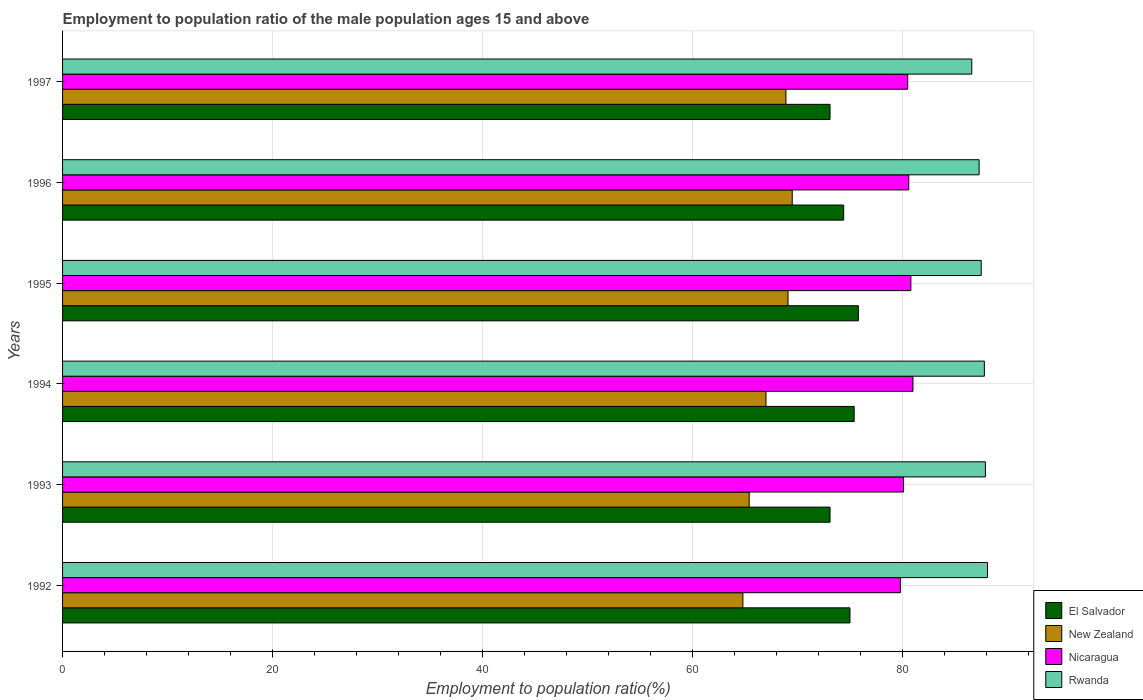How many groups of bars are there?
Keep it short and to the point. 6. Are the number of bars per tick equal to the number of legend labels?
Your response must be concise. Yes. How many bars are there on the 6th tick from the top?
Provide a short and direct response. 4. What is the label of the 5th group of bars from the top?
Give a very brief answer. 1993. What is the employment to population ratio in New Zealand in 1995?
Your response must be concise. 69.1. Across all years, what is the maximum employment to population ratio in El Salvador?
Provide a short and direct response. 75.8. Across all years, what is the minimum employment to population ratio in Nicaragua?
Provide a short and direct response. 79.8. In which year was the employment to population ratio in New Zealand maximum?
Ensure brevity in your answer.  1996. What is the total employment to population ratio in Nicaragua in the graph?
Offer a very short reply. 482.8. What is the difference between the employment to population ratio in Nicaragua in 1993 and that in 1997?
Keep it short and to the point. -0.4. What is the difference between the employment to population ratio in Nicaragua in 1992 and the employment to population ratio in El Salvador in 1994?
Your answer should be compact. 4.4. What is the average employment to population ratio in El Salvador per year?
Your response must be concise. 74.47. In the year 1993, what is the difference between the employment to population ratio in Rwanda and employment to population ratio in Nicaragua?
Offer a very short reply. 7.8. In how many years, is the employment to population ratio in Nicaragua greater than 76 %?
Ensure brevity in your answer.  6. What is the ratio of the employment to population ratio in New Zealand in 1992 to that in 1993?
Provide a succinct answer. 0.99. What is the difference between the highest and the second highest employment to population ratio in Nicaragua?
Provide a short and direct response. 0.2. What is the difference between the highest and the lowest employment to population ratio in Rwanda?
Your answer should be very brief. 1.5. Is the sum of the employment to population ratio in Rwanda in 1994 and 1996 greater than the maximum employment to population ratio in New Zealand across all years?
Ensure brevity in your answer.  Yes. Is it the case that in every year, the sum of the employment to population ratio in Nicaragua and employment to population ratio in Rwanda is greater than the sum of employment to population ratio in New Zealand and employment to population ratio in El Salvador?
Make the answer very short. Yes. What does the 1st bar from the top in 1997 represents?
Give a very brief answer. Rwanda. What does the 3rd bar from the bottom in 1993 represents?
Provide a short and direct response. Nicaragua. Is it the case that in every year, the sum of the employment to population ratio in Nicaragua and employment to population ratio in El Salvador is greater than the employment to population ratio in New Zealand?
Your answer should be compact. Yes. Are all the bars in the graph horizontal?
Your answer should be compact. Yes. How many years are there in the graph?
Your answer should be compact. 6. What is the difference between two consecutive major ticks on the X-axis?
Offer a terse response. 20. Are the values on the major ticks of X-axis written in scientific E-notation?
Your answer should be compact. No. Does the graph contain any zero values?
Your answer should be compact. No. How many legend labels are there?
Ensure brevity in your answer.  4. What is the title of the graph?
Offer a terse response. Employment to population ratio of the male population ages 15 and above. What is the label or title of the X-axis?
Keep it short and to the point. Employment to population ratio(%). What is the label or title of the Y-axis?
Your answer should be compact. Years. What is the Employment to population ratio(%) of El Salvador in 1992?
Your answer should be very brief. 75. What is the Employment to population ratio(%) of New Zealand in 1992?
Ensure brevity in your answer.  64.8. What is the Employment to population ratio(%) of Nicaragua in 1992?
Your answer should be compact. 79.8. What is the Employment to population ratio(%) of Rwanda in 1992?
Offer a very short reply. 88.1. What is the Employment to population ratio(%) in El Salvador in 1993?
Your answer should be very brief. 73.1. What is the Employment to population ratio(%) of New Zealand in 1993?
Provide a succinct answer. 65.4. What is the Employment to population ratio(%) in Nicaragua in 1993?
Provide a short and direct response. 80.1. What is the Employment to population ratio(%) of Rwanda in 1993?
Offer a terse response. 87.9. What is the Employment to population ratio(%) in El Salvador in 1994?
Your answer should be compact. 75.4. What is the Employment to population ratio(%) in New Zealand in 1994?
Provide a short and direct response. 67. What is the Employment to population ratio(%) of Nicaragua in 1994?
Keep it short and to the point. 81. What is the Employment to population ratio(%) of Rwanda in 1994?
Provide a succinct answer. 87.8. What is the Employment to population ratio(%) of El Salvador in 1995?
Your answer should be compact. 75.8. What is the Employment to population ratio(%) of New Zealand in 1995?
Offer a terse response. 69.1. What is the Employment to population ratio(%) of Nicaragua in 1995?
Offer a terse response. 80.8. What is the Employment to population ratio(%) in Rwanda in 1995?
Provide a short and direct response. 87.5. What is the Employment to population ratio(%) in El Salvador in 1996?
Your answer should be compact. 74.4. What is the Employment to population ratio(%) in New Zealand in 1996?
Ensure brevity in your answer.  69.5. What is the Employment to population ratio(%) of Nicaragua in 1996?
Keep it short and to the point. 80.6. What is the Employment to population ratio(%) in Rwanda in 1996?
Offer a terse response. 87.3. What is the Employment to population ratio(%) in El Salvador in 1997?
Your answer should be compact. 73.1. What is the Employment to population ratio(%) in New Zealand in 1997?
Your response must be concise. 68.9. What is the Employment to population ratio(%) of Nicaragua in 1997?
Provide a short and direct response. 80.5. What is the Employment to population ratio(%) of Rwanda in 1997?
Provide a short and direct response. 86.6. Across all years, what is the maximum Employment to population ratio(%) of El Salvador?
Provide a short and direct response. 75.8. Across all years, what is the maximum Employment to population ratio(%) in New Zealand?
Your response must be concise. 69.5. Across all years, what is the maximum Employment to population ratio(%) of Rwanda?
Offer a very short reply. 88.1. Across all years, what is the minimum Employment to population ratio(%) of El Salvador?
Your response must be concise. 73.1. Across all years, what is the minimum Employment to population ratio(%) of New Zealand?
Give a very brief answer. 64.8. Across all years, what is the minimum Employment to population ratio(%) of Nicaragua?
Provide a succinct answer. 79.8. Across all years, what is the minimum Employment to population ratio(%) in Rwanda?
Make the answer very short. 86.6. What is the total Employment to population ratio(%) in El Salvador in the graph?
Offer a very short reply. 446.8. What is the total Employment to population ratio(%) of New Zealand in the graph?
Offer a terse response. 404.7. What is the total Employment to population ratio(%) in Nicaragua in the graph?
Give a very brief answer. 482.8. What is the total Employment to population ratio(%) in Rwanda in the graph?
Provide a short and direct response. 525.2. What is the difference between the Employment to population ratio(%) in El Salvador in 1992 and that in 1993?
Provide a short and direct response. 1.9. What is the difference between the Employment to population ratio(%) of Nicaragua in 1992 and that in 1993?
Offer a terse response. -0.3. What is the difference between the Employment to population ratio(%) in El Salvador in 1992 and that in 1994?
Make the answer very short. -0.4. What is the difference between the Employment to population ratio(%) of New Zealand in 1992 and that in 1994?
Keep it short and to the point. -2.2. What is the difference between the Employment to population ratio(%) of El Salvador in 1992 and that in 1995?
Keep it short and to the point. -0.8. What is the difference between the Employment to population ratio(%) in Rwanda in 1992 and that in 1995?
Keep it short and to the point. 0.6. What is the difference between the Employment to population ratio(%) in El Salvador in 1992 and that in 1996?
Make the answer very short. 0.6. What is the difference between the Employment to population ratio(%) in New Zealand in 1992 and that in 1996?
Offer a very short reply. -4.7. What is the difference between the Employment to population ratio(%) of Nicaragua in 1992 and that in 1996?
Give a very brief answer. -0.8. What is the difference between the Employment to population ratio(%) in Rwanda in 1992 and that in 1996?
Ensure brevity in your answer.  0.8. What is the difference between the Employment to population ratio(%) of New Zealand in 1992 and that in 1997?
Provide a succinct answer. -4.1. What is the difference between the Employment to population ratio(%) in Nicaragua in 1992 and that in 1997?
Keep it short and to the point. -0.7. What is the difference between the Employment to population ratio(%) in El Salvador in 1993 and that in 1994?
Provide a succinct answer. -2.3. What is the difference between the Employment to population ratio(%) of Nicaragua in 1993 and that in 1994?
Offer a terse response. -0.9. What is the difference between the Employment to population ratio(%) in El Salvador in 1993 and that in 1995?
Provide a succinct answer. -2.7. What is the difference between the Employment to population ratio(%) in Rwanda in 1993 and that in 1995?
Ensure brevity in your answer.  0.4. What is the difference between the Employment to population ratio(%) of El Salvador in 1993 and that in 1996?
Offer a terse response. -1.3. What is the difference between the Employment to population ratio(%) of New Zealand in 1993 and that in 1996?
Offer a terse response. -4.1. What is the difference between the Employment to population ratio(%) of El Salvador in 1993 and that in 1997?
Your response must be concise. 0. What is the difference between the Employment to population ratio(%) in New Zealand in 1993 and that in 1997?
Ensure brevity in your answer.  -3.5. What is the difference between the Employment to population ratio(%) in Rwanda in 1993 and that in 1997?
Your response must be concise. 1.3. What is the difference between the Employment to population ratio(%) of El Salvador in 1994 and that in 1995?
Provide a succinct answer. -0.4. What is the difference between the Employment to population ratio(%) of New Zealand in 1994 and that in 1995?
Your answer should be very brief. -2.1. What is the difference between the Employment to population ratio(%) in El Salvador in 1994 and that in 1996?
Make the answer very short. 1. What is the difference between the Employment to population ratio(%) of New Zealand in 1994 and that in 1996?
Your answer should be very brief. -2.5. What is the difference between the Employment to population ratio(%) in Rwanda in 1994 and that in 1996?
Give a very brief answer. 0.5. What is the difference between the Employment to population ratio(%) in New Zealand in 1994 and that in 1997?
Make the answer very short. -1.9. What is the difference between the Employment to population ratio(%) in Rwanda in 1994 and that in 1997?
Make the answer very short. 1.2. What is the difference between the Employment to population ratio(%) of New Zealand in 1995 and that in 1996?
Offer a terse response. -0.4. What is the difference between the Employment to population ratio(%) of Rwanda in 1995 and that in 1996?
Ensure brevity in your answer.  0.2. What is the difference between the Employment to population ratio(%) in El Salvador in 1995 and that in 1997?
Your answer should be very brief. 2.7. What is the difference between the Employment to population ratio(%) in New Zealand in 1995 and that in 1997?
Your answer should be very brief. 0.2. What is the difference between the Employment to population ratio(%) in Nicaragua in 1995 and that in 1997?
Offer a terse response. 0.3. What is the difference between the Employment to population ratio(%) in Rwanda in 1995 and that in 1997?
Ensure brevity in your answer.  0.9. What is the difference between the Employment to population ratio(%) in New Zealand in 1996 and that in 1997?
Offer a very short reply. 0.6. What is the difference between the Employment to population ratio(%) in Nicaragua in 1996 and that in 1997?
Offer a very short reply. 0.1. What is the difference between the Employment to population ratio(%) in El Salvador in 1992 and the Employment to population ratio(%) in New Zealand in 1993?
Your answer should be very brief. 9.6. What is the difference between the Employment to population ratio(%) of El Salvador in 1992 and the Employment to population ratio(%) of Nicaragua in 1993?
Keep it short and to the point. -5.1. What is the difference between the Employment to population ratio(%) in New Zealand in 1992 and the Employment to population ratio(%) in Nicaragua in 1993?
Offer a very short reply. -15.3. What is the difference between the Employment to population ratio(%) in New Zealand in 1992 and the Employment to population ratio(%) in Rwanda in 1993?
Give a very brief answer. -23.1. What is the difference between the Employment to population ratio(%) of Nicaragua in 1992 and the Employment to population ratio(%) of Rwanda in 1993?
Give a very brief answer. -8.1. What is the difference between the Employment to population ratio(%) of El Salvador in 1992 and the Employment to population ratio(%) of New Zealand in 1994?
Give a very brief answer. 8. What is the difference between the Employment to population ratio(%) of El Salvador in 1992 and the Employment to population ratio(%) of Rwanda in 1994?
Give a very brief answer. -12.8. What is the difference between the Employment to population ratio(%) of New Zealand in 1992 and the Employment to population ratio(%) of Nicaragua in 1994?
Give a very brief answer. -16.2. What is the difference between the Employment to population ratio(%) in Nicaragua in 1992 and the Employment to population ratio(%) in Rwanda in 1994?
Your answer should be compact. -8. What is the difference between the Employment to population ratio(%) of El Salvador in 1992 and the Employment to population ratio(%) of Nicaragua in 1995?
Your answer should be very brief. -5.8. What is the difference between the Employment to population ratio(%) in El Salvador in 1992 and the Employment to population ratio(%) in Rwanda in 1995?
Ensure brevity in your answer.  -12.5. What is the difference between the Employment to population ratio(%) of New Zealand in 1992 and the Employment to population ratio(%) of Nicaragua in 1995?
Ensure brevity in your answer.  -16. What is the difference between the Employment to population ratio(%) of New Zealand in 1992 and the Employment to population ratio(%) of Rwanda in 1995?
Make the answer very short. -22.7. What is the difference between the Employment to population ratio(%) of Nicaragua in 1992 and the Employment to population ratio(%) of Rwanda in 1995?
Your response must be concise. -7.7. What is the difference between the Employment to population ratio(%) in El Salvador in 1992 and the Employment to population ratio(%) in New Zealand in 1996?
Offer a terse response. 5.5. What is the difference between the Employment to population ratio(%) in El Salvador in 1992 and the Employment to population ratio(%) in Nicaragua in 1996?
Your answer should be compact. -5.6. What is the difference between the Employment to population ratio(%) of El Salvador in 1992 and the Employment to population ratio(%) of Rwanda in 1996?
Provide a succinct answer. -12.3. What is the difference between the Employment to population ratio(%) of New Zealand in 1992 and the Employment to population ratio(%) of Nicaragua in 1996?
Provide a short and direct response. -15.8. What is the difference between the Employment to population ratio(%) of New Zealand in 1992 and the Employment to population ratio(%) of Rwanda in 1996?
Keep it short and to the point. -22.5. What is the difference between the Employment to population ratio(%) in Nicaragua in 1992 and the Employment to population ratio(%) in Rwanda in 1996?
Offer a terse response. -7.5. What is the difference between the Employment to population ratio(%) in El Salvador in 1992 and the Employment to population ratio(%) in New Zealand in 1997?
Provide a short and direct response. 6.1. What is the difference between the Employment to population ratio(%) in New Zealand in 1992 and the Employment to population ratio(%) in Nicaragua in 1997?
Offer a terse response. -15.7. What is the difference between the Employment to population ratio(%) in New Zealand in 1992 and the Employment to population ratio(%) in Rwanda in 1997?
Give a very brief answer. -21.8. What is the difference between the Employment to population ratio(%) of Nicaragua in 1992 and the Employment to population ratio(%) of Rwanda in 1997?
Your answer should be very brief. -6.8. What is the difference between the Employment to population ratio(%) of El Salvador in 1993 and the Employment to population ratio(%) of New Zealand in 1994?
Provide a short and direct response. 6.1. What is the difference between the Employment to population ratio(%) in El Salvador in 1993 and the Employment to population ratio(%) in Nicaragua in 1994?
Keep it short and to the point. -7.9. What is the difference between the Employment to population ratio(%) of El Salvador in 1993 and the Employment to population ratio(%) of Rwanda in 1994?
Keep it short and to the point. -14.7. What is the difference between the Employment to population ratio(%) in New Zealand in 1993 and the Employment to population ratio(%) in Nicaragua in 1994?
Make the answer very short. -15.6. What is the difference between the Employment to population ratio(%) of New Zealand in 1993 and the Employment to population ratio(%) of Rwanda in 1994?
Your answer should be very brief. -22.4. What is the difference between the Employment to population ratio(%) of El Salvador in 1993 and the Employment to population ratio(%) of Rwanda in 1995?
Your answer should be very brief. -14.4. What is the difference between the Employment to population ratio(%) in New Zealand in 1993 and the Employment to population ratio(%) in Nicaragua in 1995?
Provide a short and direct response. -15.4. What is the difference between the Employment to population ratio(%) in New Zealand in 1993 and the Employment to population ratio(%) in Rwanda in 1995?
Provide a succinct answer. -22.1. What is the difference between the Employment to population ratio(%) in El Salvador in 1993 and the Employment to population ratio(%) in New Zealand in 1996?
Give a very brief answer. 3.6. What is the difference between the Employment to population ratio(%) in New Zealand in 1993 and the Employment to population ratio(%) in Nicaragua in 1996?
Make the answer very short. -15.2. What is the difference between the Employment to population ratio(%) in New Zealand in 1993 and the Employment to population ratio(%) in Rwanda in 1996?
Provide a succinct answer. -21.9. What is the difference between the Employment to population ratio(%) of El Salvador in 1993 and the Employment to population ratio(%) of New Zealand in 1997?
Ensure brevity in your answer.  4.2. What is the difference between the Employment to population ratio(%) in El Salvador in 1993 and the Employment to population ratio(%) in Nicaragua in 1997?
Your answer should be very brief. -7.4. What is the difference between the Employment to population ratio(%) in El Salvador in 1993 and the Employment to population ratio(%) in Rwanda in 1997?
Your answer should be compact. -13.5. What is the difference between the Employment to population ratio(%) of New Zealand in 1993 and the Employment to population ratio(%) of Nicaragua in 1997?
Keep it short and to the point. -15.1. What is the difference between the Employment to population ratio(%) in New Zealand in 1993 and the Employment to population ratio(%) in Rwanda in 1997?
Provide a short and direct response. -21.2. What is the difference between the Employment to population ratio(%) of Nicaragua in 1993 and the Employment to population ratio(%) of Rwanda in 1997?
Your answer should be compact. -6.5. What is the difference between the Employment to population ratio(%) of El Salvador in 1994 and the Employment to population ratio(%) of New Zealand in 1995?
Make the answer very short. 6.3. What is the difference between the Employment to population ratio(%) in El Salvador in 1994 and the Employment to population ratio(%) in Nicaragua in 1995?
Keep it short and to the point. -5.4. What is the difference between the Employment to population ratio(%) of New Zealand in 1994 and the Employment to population ratio(%) of Nicaragua in 1995?
Provide a succinct answer. -13.8. What is the difference between the Employment to population ratio(%) of New Zealand in 1994 and the Employment to population ratio(%) of Rwanda in 1995?
Provide a succinct answer. -20.5. What is the difference between the Employment to population ratio(%) in Nicaragua in 1994 and the Employment to population ratio(%) in Rwanda in 1995?
Keep it short and to the point. -6.5. What is the difference between the Employment to population ratio(%) in El Salvador in 1994 and the Employment to population ratio(%) in New Zealand in 1996?
Make the answer very short. 5.9. What is the difference between the Employment to population ratio(%) in El Salvador in 1994 and the Employment to population ratio(%) in Rwanda in 1996?
Offer a very short reply. -11.9. What is the difference between the Employment to population ratio(%) in New Zealand in 1994 and the Employment to population ratio(%) in Rwanda in 1996?
Your answer should be very brief. -20.3. What is the difference between the Employment to population ratio(%) in Nicaragua in 1994 and the Employment to population ratio(%) in Rwanda in 1996?
Make the answer very short. -6.3. What is the difference between the Employment to population ratio(%) in El Salvador in 1994 and the Employment to population ratio(%) in Nicaragua in 1997?
Offer a very short reply. -5.1. What is the difference between the Employment to population ratio(%) in El Salvador in 1994 and the Employment to population ratio(%) in Rwanda in 1997?
Provide a short and direct response. -11.2. What is the difference between the Employment to population ratio(%) in New Zealand in 1994 and the Employment to population ratio(%) in Rwanda in 1997?
Offer a very short reply. -19.6. What is the difference between the Employment to population ratio(%) of Nicaragua in 1994 and the Employment to population ratio(%) of Rwanda in 1997?
Make the answer very short. -5.6. What is the difference between the Employment to population ratio(%) in El Salvador in 1995 and the Employment to population ratio(%) in Nicaragua in 1996?
Provide a short and direct response. -4.8. What is the difference between the Employment to population ratio(%) in New Zealand in 1995 and the Employment to population ratio(%) in Nicaragua in 1996?
Ensure brevity in your answer.  -11.5. What is the difference between the Employment to population ratio(%) in New Zealand in 1995 and the Employment to population ratio(%) in Rwanda in 1996?
Your response must be concise. -18.2. What is the difference between the Employment to population ratio(%) of New Zealand in 1995 and the Employment to population ratio(%) of Rwanda in 1997?
Give a very brief answer. -17.5. What is the difference between the Employment to population ratio(%) of Nicaragua in 1995 and the Employment to population ratio(%) of Rwanda in 1997?
Offer a terse response. -5.8. What is the difference between the Employment to population ratio(%) of El Salvador in 1996 and the Employment to population ratio(%) of Nicaragua in 1997?
Your response must be concise. -6.1. What is the difference between the Employment to population ratio(%) of New Zealand in 1996 and the Employment to population ratio(%) of Nicaragua in 1997?
Offer a terse response. -11. What is the difference between the Employment to population ratio(%) of New Zealand in 1996 and the Employment to population ratio(%) of Rwanda in 1997?
Provide a short and direct response. -17.1. What is the average Employment to population ratio(%) of El Salvador per year?
Provide a short and direct response. 74.47. What is the average Employment to population ratio(%) in New Zealand per year?
Offer a terse response. 67.45. What is the average Employment to population ratio(%) in Nicaragua per year?
Your answer should be very brief. 80.47. What is the average Employment to population ratio(%) of Rwanda per year?
Make the answer very short. 87.53. In the year 1992, what is the difference between the Employment to population ratio(%) of New Zealand and Employment to population ratio(%) of Nicaragua?
Give a very brief answer. -15. In the year 1992, what is the difference between the Employment to population ratio(%) in New Zealand and Employment to population ratio(%) in Rwanda?
Your response must be concise. -23.3. In the year 1993, what is the difference between the Employment to population ratio(%) in El Salvador and Employment to population ratio(%) in New Zealand?
Keep it short and to the point. 7.7. In the year 1993, what is the difference between the Employment to population ratio(%) in El Salvador and Employment to population ratio(%) in Rwanda?
Your answer should be compact. -14.8. In the year 1993, what is the difference between the Employment to population ratio(%) in New Zealand and Employment to population ratio(%) in Nicaragua?
Ensure brevity in your answer.  -14.7. In the year 1993, what is the difference between the Employment to population ratio(%) in New Zealand and Employment to population ratio(%) in Rwanda?
Your response must be concise. -22.5. In the year 1993, what is the difference between the Employment to population ratio(%) of Nicaragua and Employment to population ratio(%) of Rwanda?
Keep it short and to the point. -7.8. In the year 1994, what is the difference between the Employment to population ratio(%) in El Salvador and Employment to population ratio(%) in New Zealand?
Your answer should be compact. 8.4. In the year 1994, what is the difference between the Employment to population ratio(%) of New Zealand and Employment to population ratio(%) of Nicaragua?
Your response must be concise. -14. In the year 1994, what is the difference between the Employment to population ratio(%) of New Zealand and Employment to population ratio(%) of Rwanda?
Offer a terse response. -20.8. In the year 1994, what is the difference between the Employment to population ratio(%) in Nicaragua and Employment to population ratio(%) in Rwanda?
Your answer should be very brief. -6.8. In the year 1995, what is the difference between the Employment to population ratio(%) in El Salvador and Employment to population ratio(%) in New Zealand?
Ensure brevity in your answer.  6.7. In the year 1995, what is the difference between the Employment to population ratio(%) in New Zealand and Employment to population ratio(%) in Nicaragua?
Offer a very short reply. -11.7. In the year 1995, what is the difference between the Employment to population ratio(%) of New Zealand and Employment to population ratio(%) of Rwanda?
Provide a short and direct response. -18.4. In the year 1996, what is the difference between the Employment to population ratio(%) in El Salvador and Employment to population ratio(%) in New Zealand?
Your response must be concise. 4.9. In the year 1996, what is the difference between the Employment to population ratio(%) of El Salvador and Employment to population ratio(%) of Nicaragua?
Provide a succinct answer. -6.2. In the year 1996, what is the difference between the Employment to population ratio(%) of El Salvador and Employment to population ratio(%) of Rwanda?
Provide a short and direct response. -12.9. In the year 1996, what is the difference between the Employment to population ratio(%) of New Zealand and Employment to population ratio(%) of Rwanda?
Make the answer very short. -17.8. In the year 1996, what is the difference between the Employment to population ratio(%) of Nicaragua and Employment to population ratio(%) of Rwanda?
Ensure brevity in your answer.  -6.7. In the year 1997, what is the difference between the Employment to population ratio(%) of El Salvador and Employment to population ratio(%) of New Zealand?
Make the answer very short. 4.2. In the year 1997, what is the difference between the Employment to population ratio(%) in El Salvador and Employment to population ratio(%) in Nicaragua?
Your response must be concise. -7.4. In the year 1997, what is the difference between the Employment to population ratio(%) of New Zealand and Employment to population ratio(%) of Rwanda?
Your response must be concise. -17.7. In the year 1997, what is the difference between the Employment to population ratio(%) in Nicaragua and Employment to population ratio(%) in Rwanda?
Provide a short and direct response. -6.1. What is the ratio of the Employment to population ratio(%) in New Zealand in 1992 to that in 1993?
Your response must be concise. 0.99. What is the ratio of the Employment to population ratio(%) of Rwanda in 1992 to that in 1993?
Ensure brevity in your answer.  1. What is the ratio of the Employment to population ratio(%) of El Salvador in 1992 to that in 1994?
Your answer should be very brief. 0.99. What is the ratio of the Employment to population ratio(%) of New Zealand in 1992 to that in 1994?
Offer a terse response. 0.97. What is the ratio of the Employment to population ratio(%) of Nicaragua in 1992 to that in 1994?
Make the answer very short. 0.99. What is the ratio of the Employment to population ratio(%) in Rwanda in 1992 to that in 1994?
Your answer should be compact. 1. What is the ratio of the Employment to population ratio(%) in El Salvador in 1992 to that in 1995?
Offer a very short reply. 0.99. What is the ratio of the Employment to population ratio(%) of New Zealand in 1992 to that in 1995?
Offer a terse response. 0.94. What is the ratio of the Employment to population ratio(%) of Nicaragua in 1992 to that in 1995?
Your answer should be compact. 0.99. What is the ratio of the Employment to population ratio(%) in Rwanda in 1992 to that in 1995?
Offer a very short reply. 1.01. What is the ratio of the Employment to population ratio(%) in El Salvador in 1992 to that in 1996?
Provide a short and direct response. 1.01. What is the ratio of the Employment to population ratio(%) of New Zealand in 1992 to that in 1996?
Provide a short and direct response. 0.93. What is the ratio of the Employment to population ratio(%) of Rwanda in 1992 to that in 1996?
Your answer should be compact. 1.01. What is the ratio of the Employment to population ratio(%) of El Salvador in 1992 to that in 1997?
Your answer should be very brief. 1.03. What is the ratio of the Employment to population ratio(%) of New Zealand in 1992 to that in 1997?
Offer a terse response. 0.94. What is the ratio of the Employment to population ratio(%) of Rwanda in 1992 to that in 1997?
Provide a short and direct response. 1.02. What is the ratio of the Employment to population ratio(%) in El Salvador in 1993 to that in 1994?
Ensure brevity in your answer.  0.97. What is the ratio of the Employment to population ratio(%) in New Zealand in 1993 to that in 1994?
Provide a succinct answer. 0.98. What is the ratio of the Employment to population ratio(%) of Nicaragua in 1993 to that in 1994?
Make the answer very short. 0.99. What is the ratio of the Employment to population ratio(%) in Rwanda in 1993 to that in 1994?
Provide a succinct answer. 1. What is the ratio of the Employment to population ratio(%) in El Salvador in 1993 to that in 1995?
Your answer should be very brief. 0.96. What is the ratio of the Employment to population ratio(%) of New Zealand in 1993 to that in 1995?
Your answer should be very brief. 0.95. What is the ratio of the Employment to population ratio(%) of Rwanda in 1993 to that in 1995?
Offer a terse response. 1. What is the ratio of the Employment to population ratio(%) of El Salvador in 1993 to that in 1996?
Provide a succinct answer. 0.98. What is the ratio of the Employment to population ratio(%) of New Zealand in 1993 to that in 1996?
Keep it short and to the point. 0.94. What is the ratio of the Employment to population ratio(%) in Nicaragua in 1993 to that in 1996?
Provide a succinct answer. 0.99. What is the ratio of the Employment to population ratio(%) of Rwanda in 1993 to that in 1996?
Ensure brevity in your answer.  1.01. What is the ratio of the Employment to population ratio(%) in New Zealand in 1993 to that in 1997?
Make the answer very short. 0.95. What is the ratio of the Employment to population ratio(%) in New Zealand in 1994 to that in 1995?
Make the answer very short. 0.97. What is the ratio of the Employment to population ratio(%) of El Salvador in 1994 to that in 1996?
Offer a very short reply. 1.01. What is the ratio of the Employment to population ratio(%) of Nicaragua in 1994 to that in 1996?
Offer a terse response. 1. What is the ratio of the Employment to population ratio(%) of Rwanda in 1994 to that in 1996?
Keep it short and to the point. 1.01. What is the ratio of the Employment to population ratio(%) in El Salvador in 1994 to that in 1997?
Offer a very short reply. 1.03. What is the ratio of the Employment to population ratio(%) of New Zealand in 1994 to that in 1997?
Provide a succinct answer. 0.97. What is the ratio of the Employment to population ratio(%) of Nicaragua in 1994 to that in 1997?
Give a very brief answer. 1.01. What is the ratio of the Employment to population ratio(%) of Rwanda in 1994 to that in 1997?
Offer a very short reply. 1.01. What is the ratio of the Employment to population ratio(%) of El Salvador in 1995 to that in 1996?
Provide a short and direct response. 1.02. What is the ratio of the Employment to population ratio(%) in New Zealand in 1995 to that in 1996?
Your response must be concise. 0.99. What is the ratio of the Employment to population ratio(%) of El Salvador in 1995 to that in 1997?
Ensure brevity in your answer.  1.04. What is the ratio of the Employment to population ratio(%) of Rwanda in 1995 to that in 1997?
Provide a succinct answer. 1.01. What is the ratio of the Employment to population ratio(%) of El Salvador in 1996 to that in 1997?
Provide a short and direct response. 1.02. What is the ratio of the Employment to population ratio(%) of New Zealand in 1996 to that in 1997?
Give a very brief answer. 1.01. What is the difference between the highest and the lowest Employment to population ratio(%) of El Salvador?
Ensure brevity in your answer.  2.7. What is the difference between the highest and the lowest Employment to population ratio(%) of Nicaragua?
Keep it short and to the point. 1.2. What is the difference between the highest and the lowest Employment to population ratio(%) in Rwanda?
Make the answer very short. 1.5. 